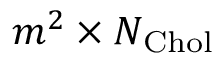<formula> <loc_0><loc_0><loc_500><loc_500>m ^ { 2 } \times N _ { C h o l }</formula> 